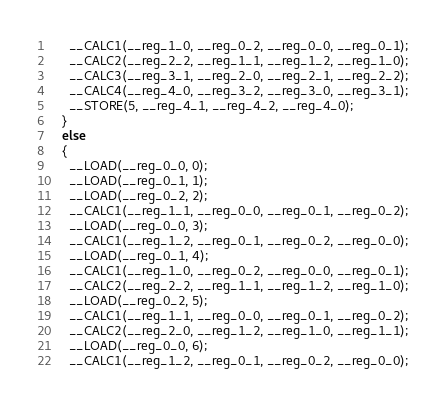Convert code to text. <code><loc_0><loc_0><loc_500><loc_500><_Cuda_>      __CALC1(__reg_1_0, __reg_0_2, __reg_0_0, __reg_0_1);
      __CALC2(__reg_2_2, __reg_1_1, __reg_1_2, __reg_1_0);
      __CALC3(__reg_3_1, __reg_2_0, __reg_2_1, __reg_2_2);
      __CALC4(__reg_4_0, __reg_3_2, __reg_3_0, __reg_3_1);
      __STORE(5, __reg_4_1, __reg_4_2, __reg_4_0);
    }
    else
    {
      __LOAD(__reg_0_0, 0);
      __LOAD(__reg_0_1, 1);
      __LOAD(__reg_0_2, 2);
      __CALC1(__reg_1_1, __reg_0_0, __reg_0_1, __reg_0_2);
      __LOAD(__reg_0_0, 3);
      __CALC1(__reg_1_2, __reg_0_1, __reg_0_2, __reg_0_0);
      __LOAD(__reg_0_1, 4);
      __CALC1(__reg_1_0, __reg_0_2, __reg_0_0, __reg_0_1);
      __CALC2(__reg_2_2, __reg_1_1, __reg_1_2, __reg_1_0);
      __LOAD(__reg_0_2, 5);
      __CALC1(__reg_1_1, __reg_0_0, __reg_0_1, __reg_0_2);
      __CALC2(__reg_2_0, __reg_1_2, __reg_1_0, __reg_1_1);
      __LOAD(__reg_0_0, 6);
      __CALC1(__reg_1_2, __reg_0_1, __reg_0_2, __reg_0_0);</code> 